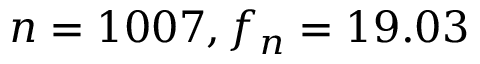<formula> <loc_0><loc_0><loc_500><loc_500>n = 1 0 0 7 , f _ { n } = 1 9 . 0 3</formula> 